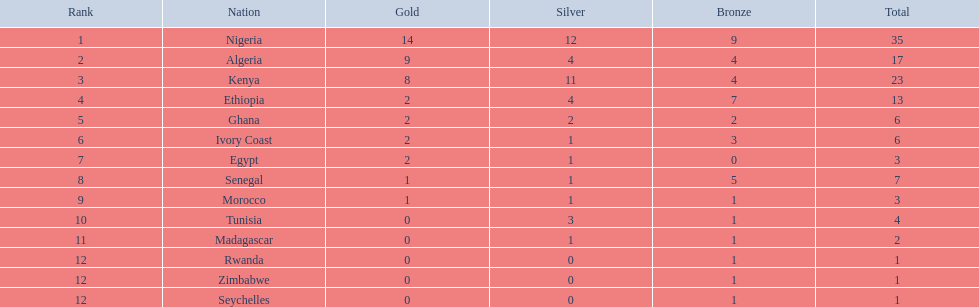What are all the countries? Nigeria, Algeria, Kenya, Ethiopia, Ghana, Ivory Coast, Egypt, Senegal, Morocco, Tunisia, Madagascar, Rwanda, Zimbabwe, Seychelles. How many bronze medals did they earn? 9, 4, 4, 7, 2, 3, 0, 5, 1, 1, 1, 1, 1, 1. And which country did not secure one? Egypt. 